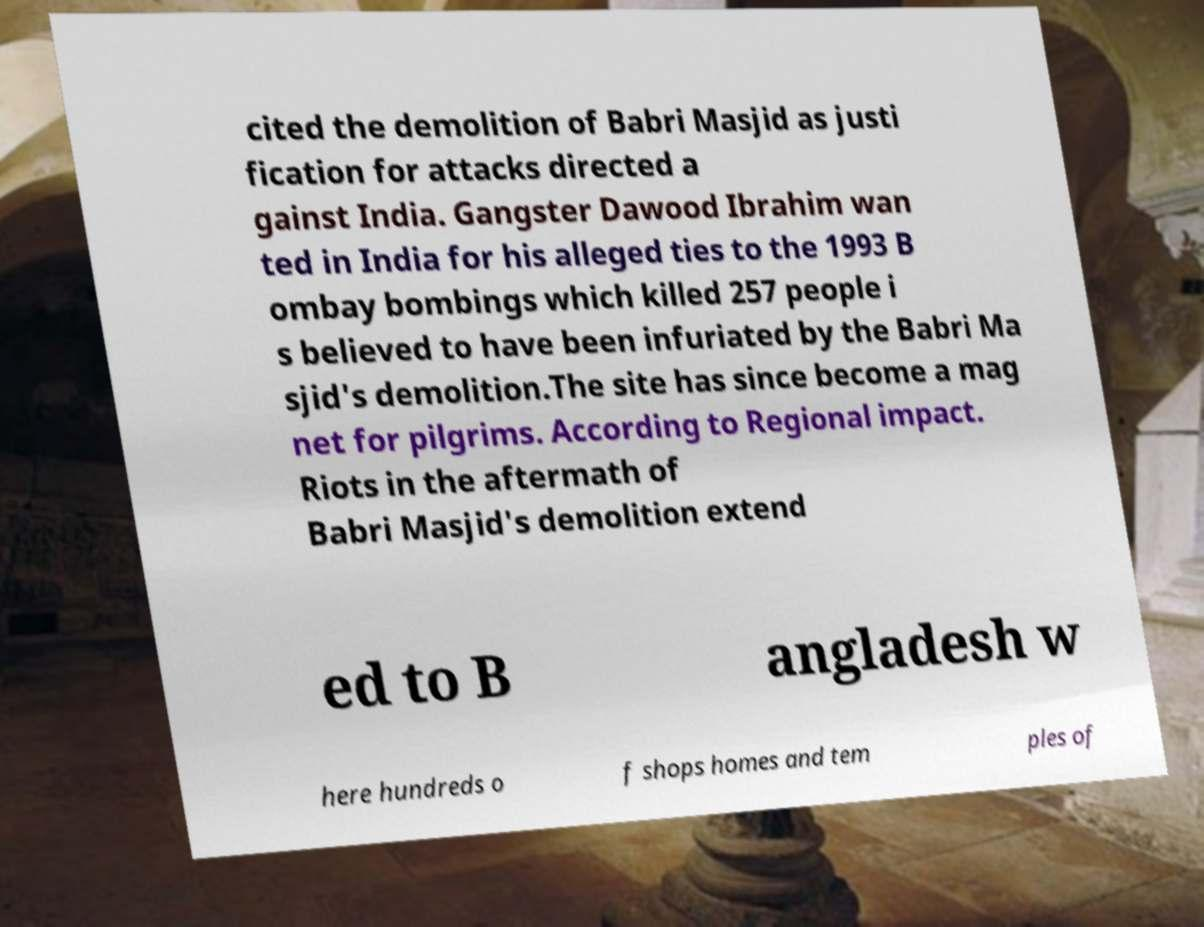Can you accurately transcribe the text from the provided image for me? cited the demolition of Babri Masjid as justi fication for attacks directed a gainst India. Gangster Dawood Ibrahim wan ted in India for his alleged ties to the 1993 B ombay bombings which killed 257 people i s believed to have been infuriated by the Babri Ma sjid's demolition.The site has since become a mag net for pilgrims. According to Regional impact. Riots in the aftermath of Babri Masjid's demolition extend ed to B angladesh w here hundreds o f shops homes and tem ples of 